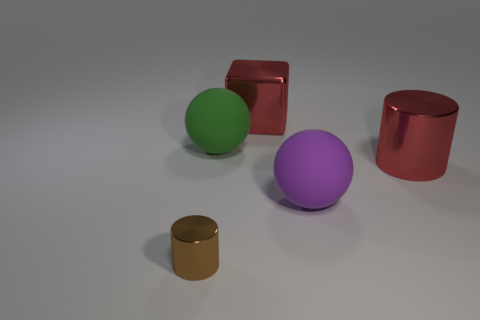The big object that is the same color as the large metal cube is what shape?
Keep it short and to the point. Cylinder. The object that is both to the right of the big red metallic block and in front of the big cylinder is made of what material?
Make the answer very short. Rubber. What size is the brown thing?
Provide a short and direct response. Small. There is a large metal object that is on the left side of the big red metal object that is in front of the large red cube; how many big green objects are behind it?
Provide a short and direct response. 0. The big object that is in front of the metallic cylinder that is to the right of the tiny cylinder is what shape?
Your answer should be very brief. Sphere. What size is the purple matte object that is the same shape as the green rubber object?
Provide a short and direct response. Large. Is there anything else that is the same size as the green ball?
Offer a terse response. Yes. There is a cylinder that is behind the small thing; what color is it?
Give a very brief answer. Red. The sphere behind the big red metallic thing in front of the large matte ball that is behind the red cylinder is made of what material?
Offer a very short reply. Rubber. What is the size of the shiny cylinder behind the cylinder in front of the large purple rubber object?
Your response must be concise. Large. 